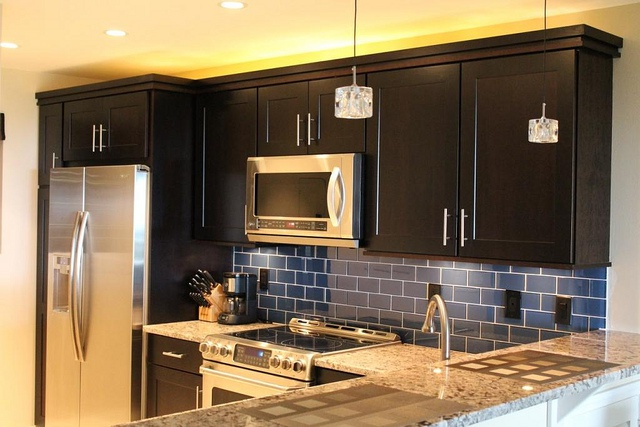Describe the objects in this image and their specific colors. I can see refrigerator in tan and gray tones, microwave in tan and maroon tones, oven in tan, black, and maroon tones, knife in tan, black, maroon, and gray tones, and knife in tan, black, and gray tones in this image. 